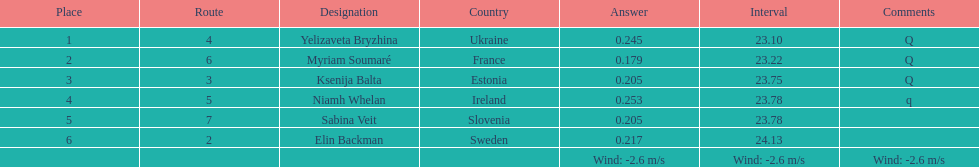Which player is from ireland? Niamh Whelan. 